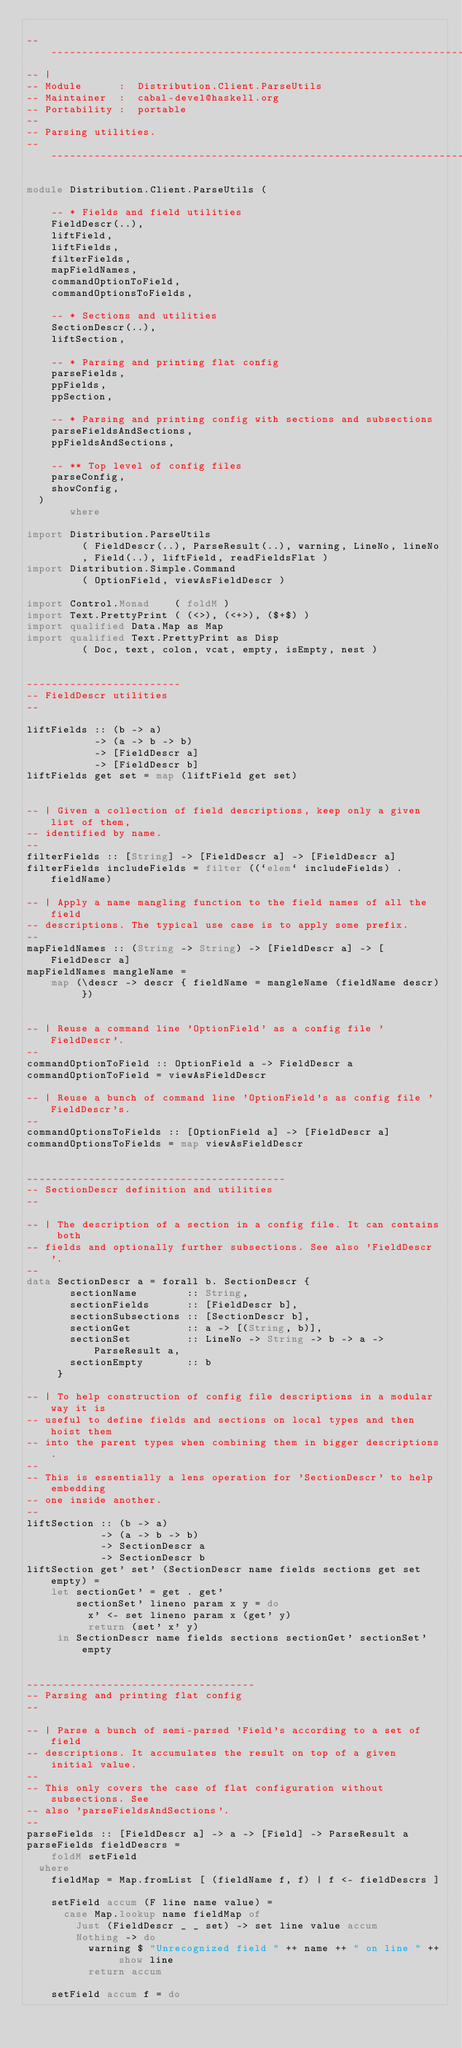Convert code to text. <code><loc_0><loc_0><loc_500><loc_500><_Haskell_>
-----------------------------------------------------------------------------
-- |
-- Module      :  Distribution.Client.ParseUtils
-- Maintainer  :  cabal-devel@haskell.org
-- Portability :  portable
--
-- Parsing utilities.
-----------------------------------------------------------------------------

module Distribution.Client.ParseUtils (

    -- * Fields and field utilities
    FieldDescr(..),
    liftField,
    liftFields,
    filterFields,
    mapFieldNames,
    commandOptionToField,
    commandOptionsToFields,

    -- * Sections and utilities
    SectionDescr(..),
    liftSection,

    -- * Parsing and printing flat config
    parseFields,
    ppFields,
    ppSection,

    -- * Parsing and printing config with sections and subsections
    parseFieldsAndSections,
    ppFieldsAndSections,

    -- ** Top level of config files
    parseConfig,
    showConfig,
  )
       where

import Distribution.ParseUtils
         ( FieldDescr(..), ParseResult(..), warning, LineNo, lineNo
         , Field(..), liftField, readFieldsFlat )
import Distribution.Simple.Command
         ( OptionField, viewAsFieldDescr )

import Control.Monad    ( foldM )
import Text.PrettyPrint ( (<>), (<+>), ($+$) )
import qualified Data.Map as Map
import qualified Text.PrettyPrint as Disp
         ( Doc, text, colon, vcat, empty, isEmpty, nest )


-------------------------
-- FieldDescr utilities
--

liftFields :: (b -> a)
           -> (a -> b -> b)
           -> [FieldDescr a]
           -> [FieldDescr b]
liftFields get set = map (liftField get set)


-- | Given a collection of field descriptions, keep only a given list of them,
-- identified by name.
--
filterFields :: [String] -> [FieldDescr a] -> [FieldDescr a]
filterFields includeFields = filter ((`elem` includeFields) . fieldName)

-- | Apply a name mangling function to the field names of all the field
-- descriptions. The typical use case is to apply some prefix.
--
mapFieldNames :: (String -> String) -> [FieldDescr a] -> [FieldDescr a]
mapFieldNames mangleName =
    map (\descr -> descr { fieldName = mangleName (fieldName descr) })


-- | Reuse a command line 'OptionField' as a config file 'FieldDescr'.
--
commandOptionToField :: OptionField a -> FieldDescr a
commandOptionToField = viewAsFieldDescr

-- | Reuse a bunch of command line 'OptionField's as config file 'FieldDescr's.
--
commandOptionsToFields :: [OptionField a] -> [FieldDescr a]
commandOptionsToFields = map viewAsFieldDescr


------------------------------------------
-- SectionDescr definition and utilities
--

-- | The description of a section in a config file. It can contains both
-- fields and optionally further subsections. See also 'FieldDescr'.
--
data SectionDescr a = forall b. SectionDescr {
       sectionName        :: String,
       sectionFields      :: [FieldDescr b],
       sectionSubsections :: [SectionDescr b],
       sectionGet         :: a -> [(String, b)],
       sectionSet         :: LineNo -> String -> b -> a -> ParseResult a,
       sectionEmpty       :: b
     }

-- | To help construction of config file descriptions in a modular way it is
-- useful to define fields and sections on local types and then hoist them
-- into the parent types when combining them in bigger descriptions.
--
-- This is essentially a lens operation for 'SectionDescr' to help embedding
-- one inside another.
--
liftSection :: (b -> a)
            -> (a -> b -> b)
            -> SectionDescr a
            -> SectionDescr b
liftSection get' set' (SectionDescr name fields sections get set empty) =
    let sectionGet' = get . get'
        sectionSet' lineno param x y = do
          x' <- set lineno param x (get' y)
          return (set' x' y)
     in SectionDescr name fields sections sectionGet' sectionSet' empty


-------------------------------------
-- Parsing and printing flat config
--

-- | Parse a bunch of semi-parsed 'Field's according to a set of field
-- descriptions. It accumulates the result on top of a given initial value.
--
-- This only covers the case of flat configuration without subsections. See
-- also 'parseFieldsAndSections'.
--
parseFields :: [FieldDescr a] -> a -> [Field] -> ParseResult a
parseFields fieldDescrs =
    foldM setField
  where
    fieldMap = Map.fromList [ (fieldName f, f) | f <- fieldDescrs ]

    setField accum (F line name value) =
      case Map.lookup name fieldMap of
        Just (FieldDescr _ _ set) -> set line value accum
        Nothing -> do
          warning $ "Unrecognized field " ++ name ++ " on line " ++ show line
          return accum

    setField accum f = do</code> 